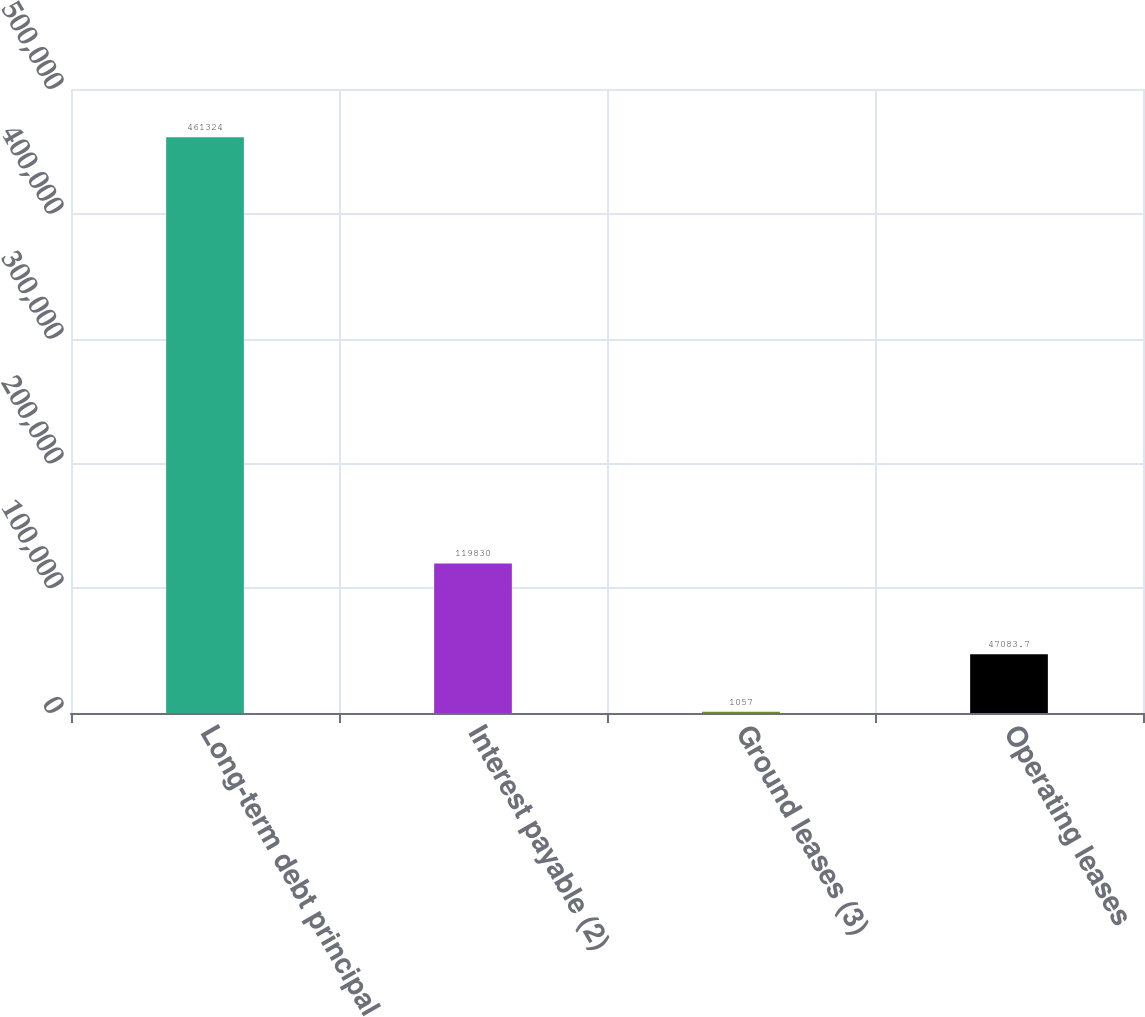<chart> <loc_0><loc_0><loc_500><loc_500><bar_chart><fcel>Long-term debt principal<fcel>Interest payable (2)<fcel>Ground leases (3)<fcel>Operating leases<nl><fcel>461324<fcel>119830<fcel>1057<fcel>47083.7<nl></chart> 